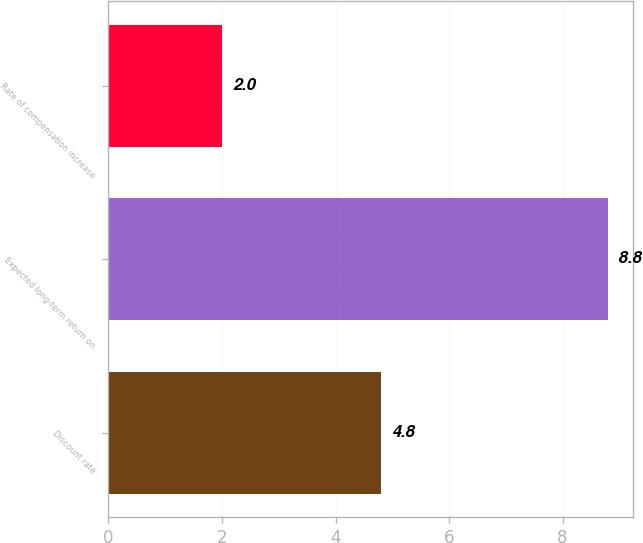Convert chart to OTSL. <chart><loc_0><loc_0><loc_500><loc_500><bar_chart><fcel>Discount rate<fcel>Expected long-term return on<fcel>Rate of compensation increase<nl><fcel>4.8<fcel>8.8<fcel>2<nl></chart> 